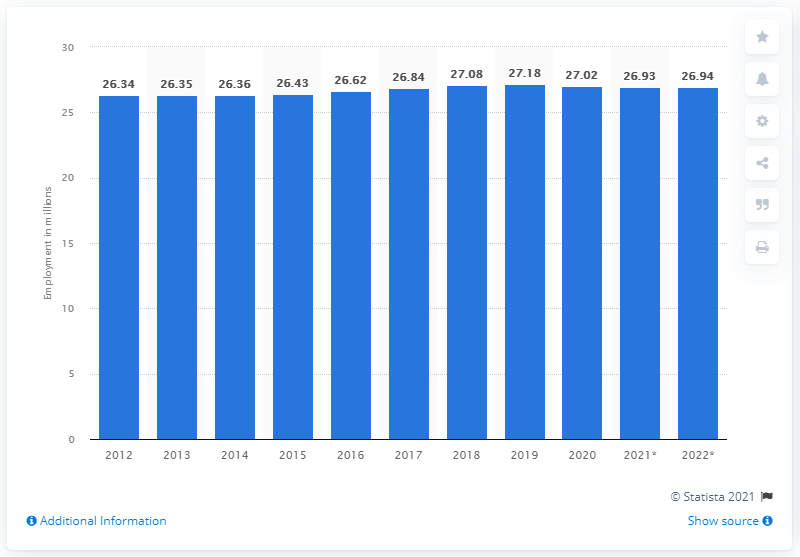Draw attention to some important aspects in this diagram. In the year 2020, employment in France came to an end. In 2020, it was reported that 26.94 people were employed in France. In 2020, employment in France came to an end. 